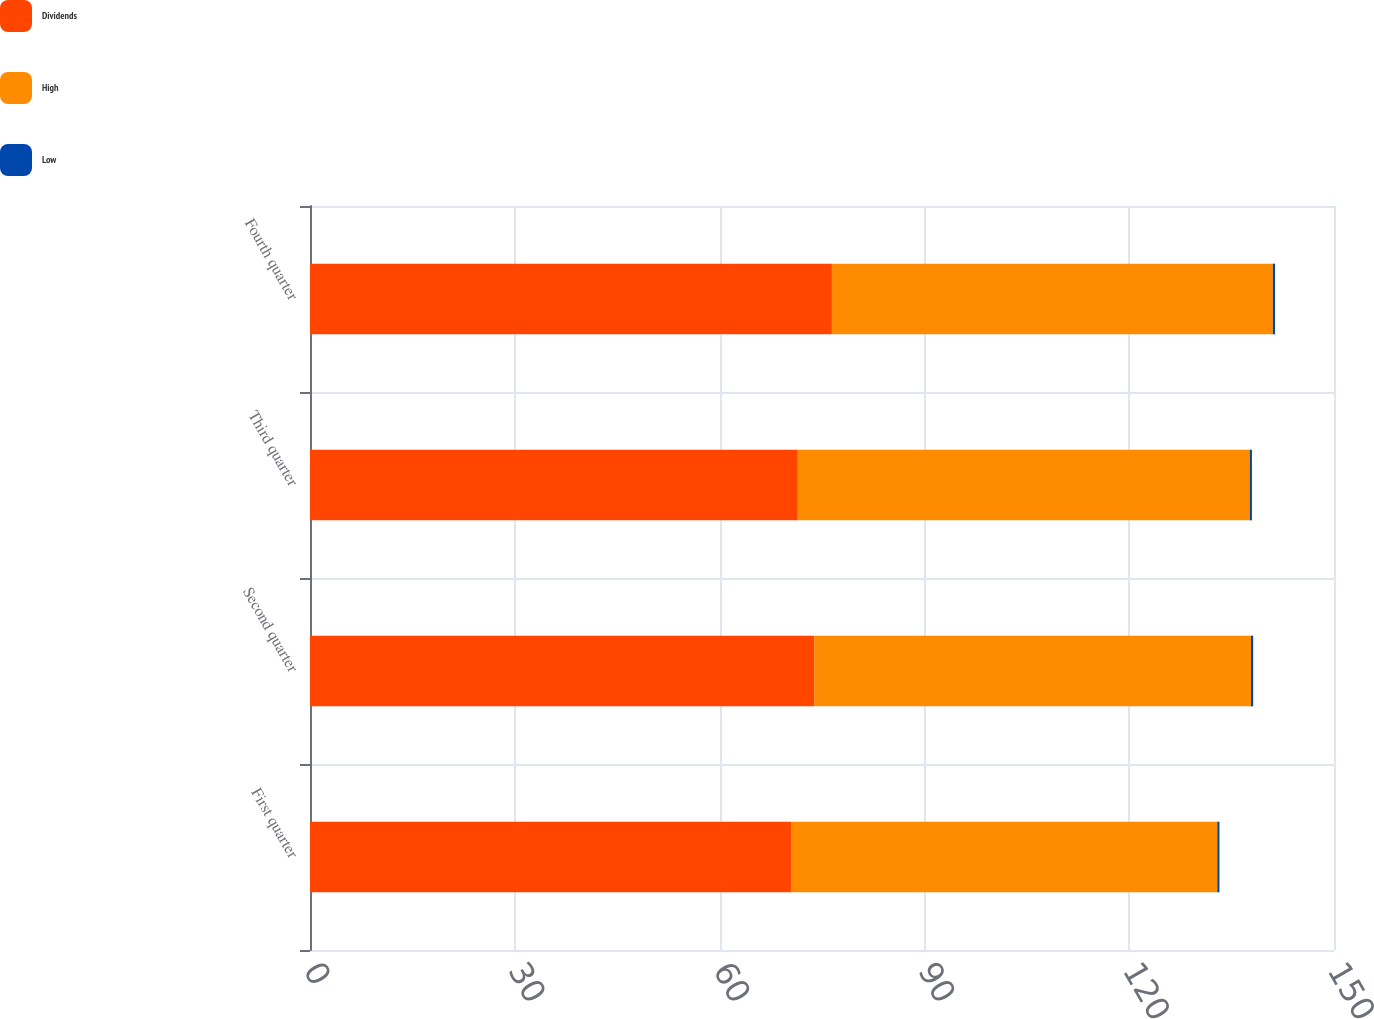Convert chart to OTSL. <chart><loc_0><loc_0><loc_500><loc_500><stacked_bar_chart><ecel><fcel>First quarter<fcel>Second quarter<fcel>Third quarter<fcel>Fourth quarter<nl><fcel>Dividends<fcel>70.55<fcel>73.86<fcel>71.45<fcel>76.45<nl><fcel>High<fcel>62.35<fcel>63.98<fcel>66.21<fcel>64.59<nl><fcel>Low<fcel>0.32<fcel>0.32<fcel>0.32<fcel>0.32<nl></chart> 